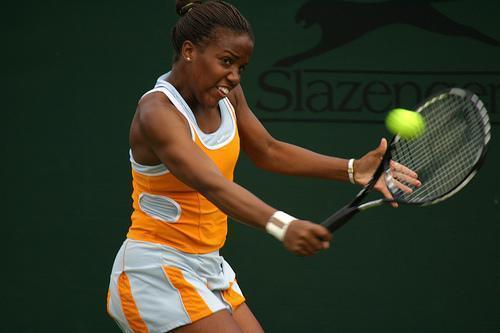How many people are seen?
Give a very brief answer. 1. 